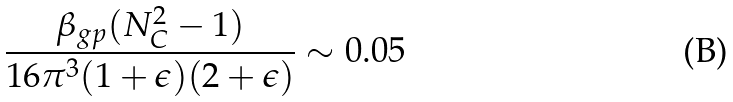Convert formula to latex. <formula><loc_0><loc_0><loc_500><loc_500>\frac { \beta _ { g p } ( N _ { C } ^ { 2 } - 1 ) } { 1 6 \pi ^ { 3 } ( 1 + \epsilon ) ( 2 + \epsilon ) } \sim 0 . 0 5</formula> 